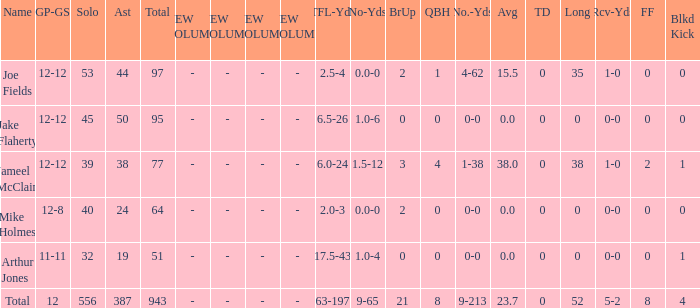How many players named jake flaherty? 1.0. Give me the full table as a dictionary. {'header': ['Name', 'GP-GS', 'Solo', 'Ast', 'Total', 'NEW COLUMN 1', 'NEW COLUMN 2', 'NEW COLUMN 3', 'NEW COLUMN 4', 'TFL-Yds', 'No-Yds', 'BrUp', 'QBH', 'No.-Yds', 'Avg', 'TD', 'Long', 'Rcv-Yds', 'FF', 'Blkd Kick'], 'rows': [['Joe Fields', '12-12', '53', '44', '97', '-', '-', '-', '-', '2.5-4', '0.0-0', '2', '1', '4-62', '15.5', '0', '35', '1-0', '0', '0'], ['Jake Flaherty', '12-12', '45', '50', '95', '-', '-', '-', '-', '6.5-26', '1.0-6', '0', '0', '0-0', '0.0', '0', '0', '0-0', '0', '0'], ['Jameel McClain', '12-12', '39', '38', '77', '-', '-', '-', '-', '6.0-24', '1.5-12', '3', '4', '1-38', '38.0', '0', '38', '1-0', '2', '1'], ['Mike Holmes', '12-8', '40', '24', '64', '-', '-', '-', '-', '2.0-3', '0.0-0', '2', '0', '0-0', '0.0', '0', '0', '0-0', '0', '0'], ['Arthur Jones', '11-11', '32', '19', '51', '-', '-', '-', '-', '17.5-43', '1.0-4', '0', '0', '0-0', '0.0', '0', '0', '0-0', '0', '1'], ['Total', '12', '556', '387', '943', '-', '-', '-', '-', '63-197', '9-65', '21', '8', '9-213', '23.7', '0', '52', '5-2', '8', '4']]} 